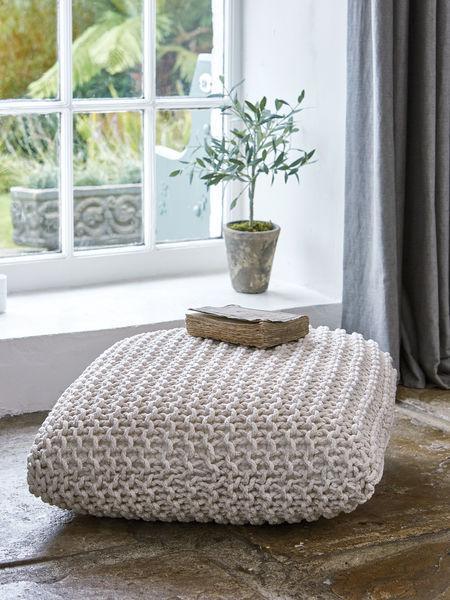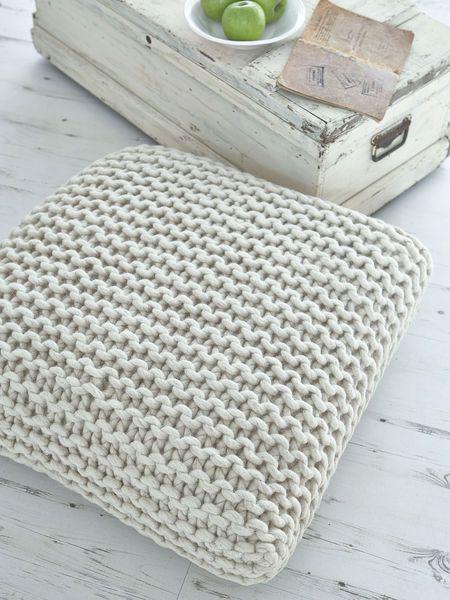The first image is the image on the left, the second image is the image on the right. Examine the images to the left and right. Is the description "Each image contains a squarish knit pillow made of chunky yarn, and at least one image features such a pillow in a cream color." accurate? Answer yes or no. Yes. The first image is the image on the left, the second image is the image on the right. Examine the images to the left and right. Is the description "There are at least 3 crochet pillow stacked on top of each other." accurate? Answer yes or no. No. 